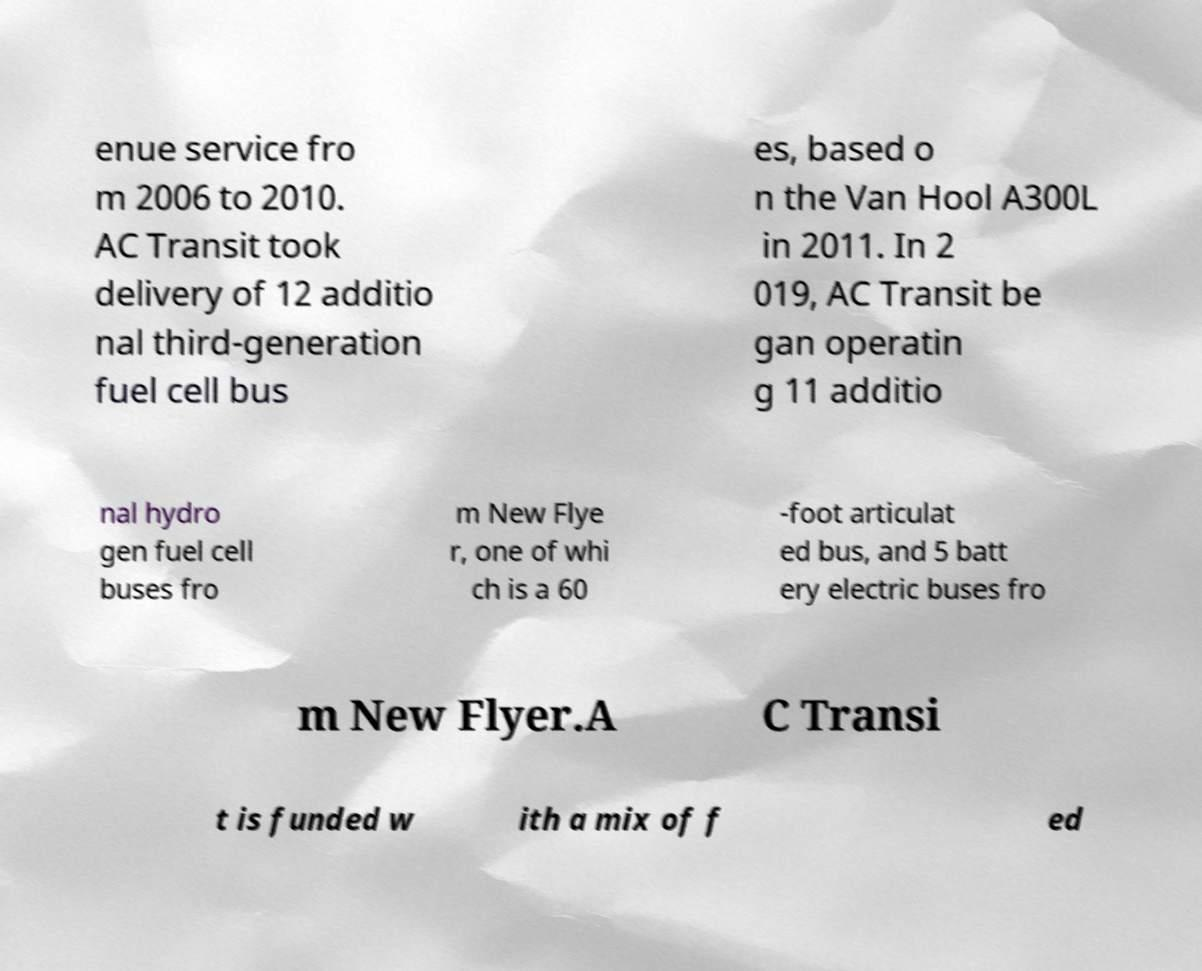For documentation purposes, I need the text within this image transcribed. Could you provide that? enue service fro m 2006 to 2010. AC Transit took delivery of 12 additio nal third-generation fuel cell bus es, based o n the Van Hool A300L in 2011. In 2 019, AC Transit be gan operatin g 11 additio nal hydro gen fuel cell buses fro m New Flye r, one of whi ch is a 60 -foot articulat ed bus, and 5 batt ery electric buses fro m New Flyer.A C Transi t is funded w ith a mix of f ed 